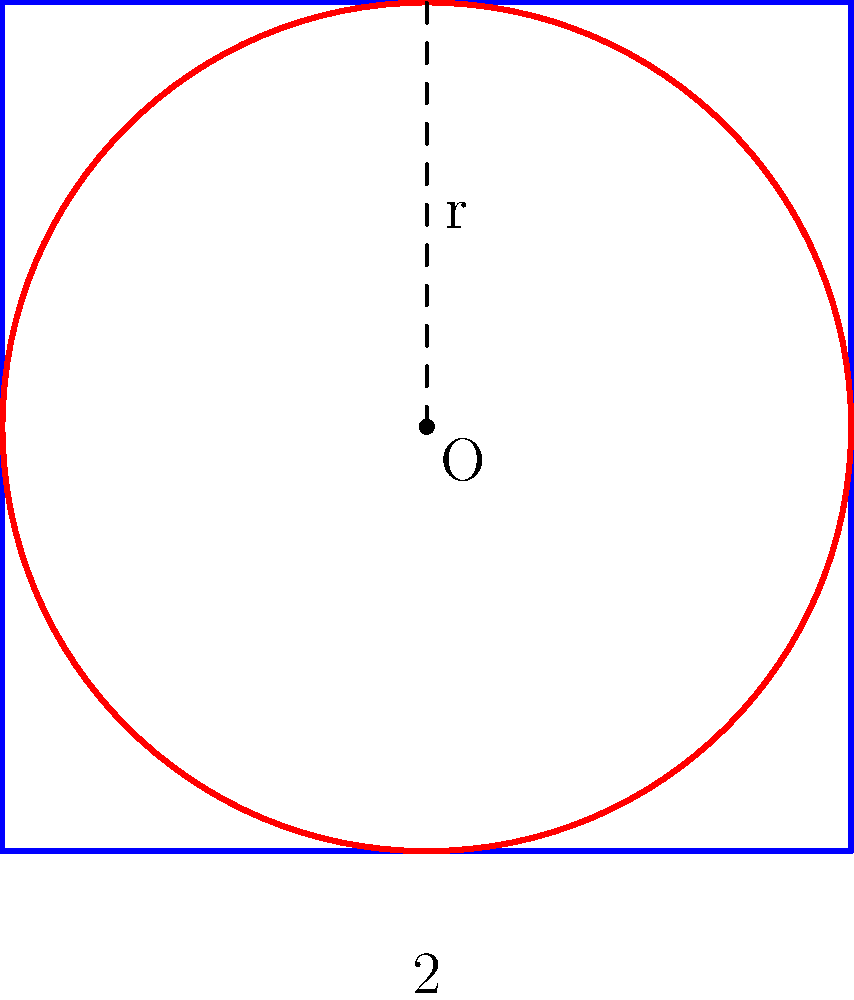As a glass artist, you're designing a circular glass piece to fit perfectly within a square frame. The square has sides of length 2 units. Derive the equation of the circle that fits exactly within this square, with its center at the origin (0,0). Let's approach this step-by-step:

1) The square is centered at the origin (0,0) and has sides of length 2 units. This means its vertices are at (-1,-1), (1,-1), (1,1), and (-1,1).

2) The circle we want to find will touch all four sides of the square. Its center will coincide with the center of the square, which is at (0,0).

3) The radius of the circle will be half the length of the square's side. Since the side length is 2 units, the radius will be 1 unit.

4) The general equation of a circle with center (h,k) and radius r is:

   $$(x-h)^2 + (y-k)^2 = r^2$$

5) In our case:
   - The center is at (0,0), so h = 0 and k = 0
   - The radius is 1, so r = 1

6) Substituting these values into the general equation:

   $$(x-0)^2 + (y-0)^2 = 1^2$$

7) Simplifying:

   $$x^2 + y^2 = 1$$

This is the equation of the circle that fits perfectly within the square.
Answer: $x^2 + y^2 = 1$ 